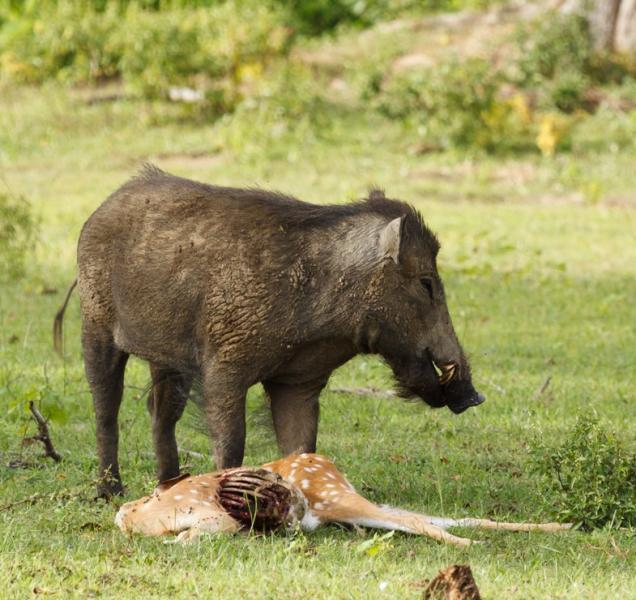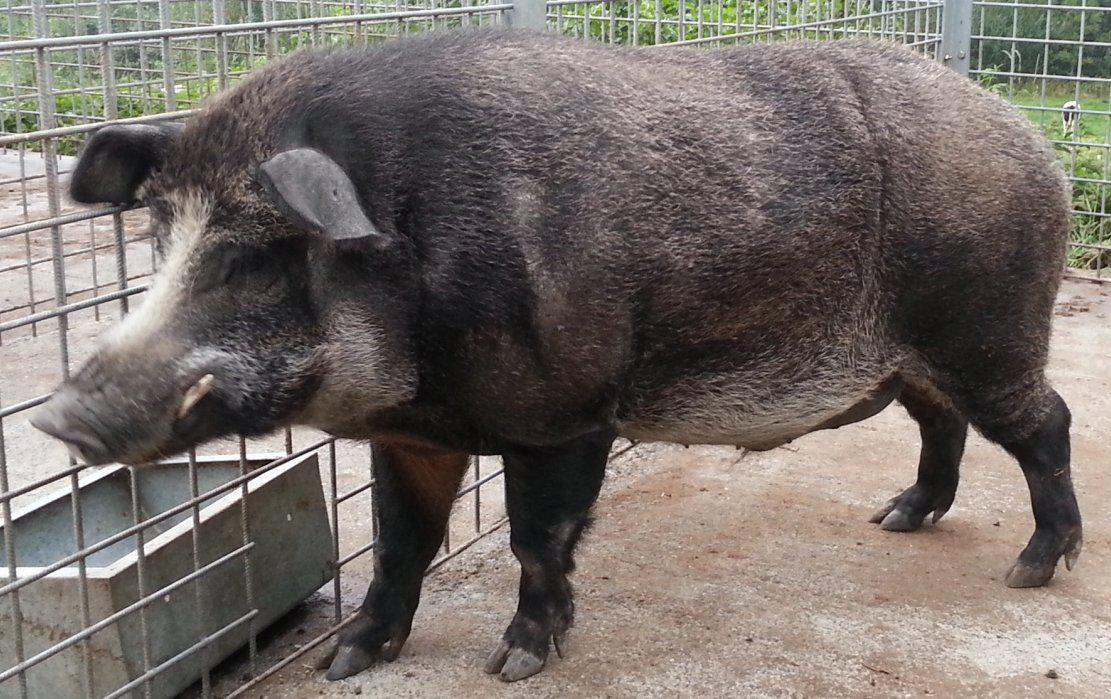The first image is the image on the left, the second image is the image on the right. Examine the images to the left and right. Is the description "There are two hogs in the pair of images ,both facing each other." accurate? Answer yes or no. Yes. The first image is the image on the left, the second image is the image on the right. For the images displayed, is the sentence "Each image contains a single wild pig, and the pigs in the right and left images appear to be facing each other." factually correct? Answer yes or no. Yes. 